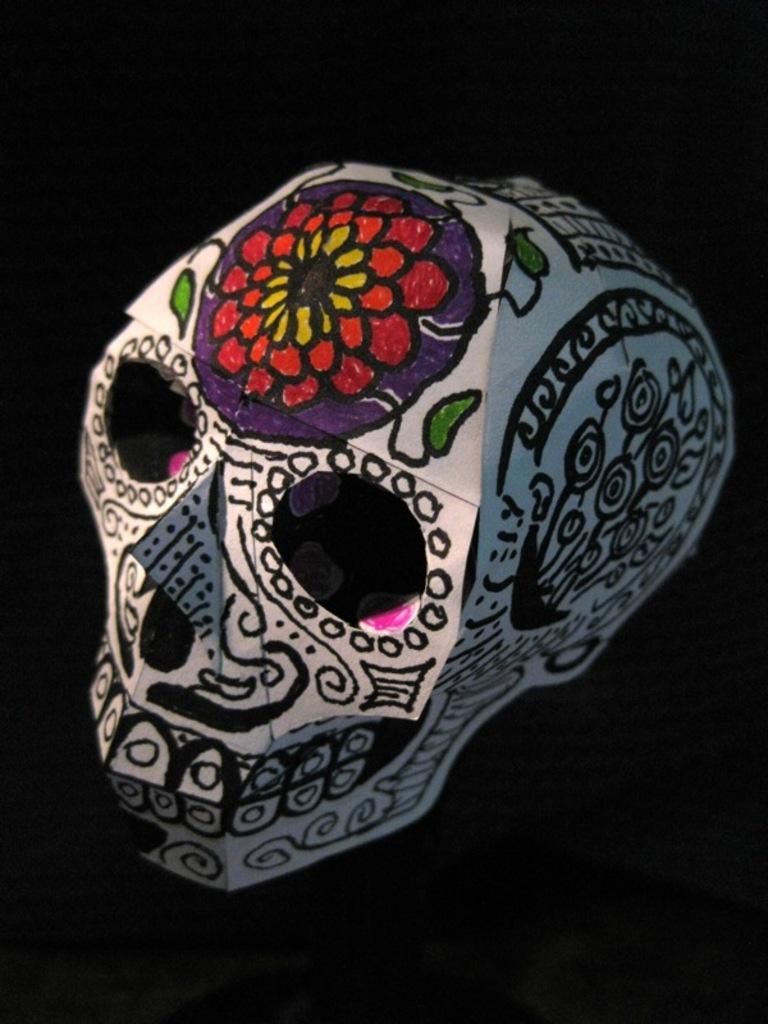How would you summarize this image in a sentence or two? The picture consists of catalog of a skull, on the skull there are rangolis and drawings. The background is dark. 